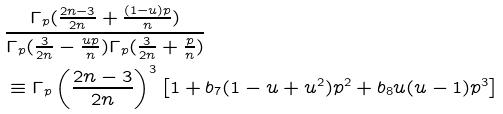<formula> <loc_0><loc_0><loc_500><loc_500>& \frac { \Gamma _ { p } ( \frac { 2 n - 3 } { 2 n } + \frac { ( 1 - u ) p } { n } ) } { \Gamma _ { p } ( \frac { 3 } { 2 n } - \frac { u p } { n } ) \Gamma _ { p } ( \frac { 3 } { 2 n } + \frac { p } { n } ) } \\ & \equiv \Gamma _ { p } \left ( \frac { 2 n - 3 } { 2 n } \right ) ^ { 3 } \left [ 1 + b _ { 7 } ( 1 - u + u ^ { 2 } ) p ^ { 2 } + b _ { 8 } u ( u - 1 ) p ^ { 3 } \right ]</formula> 